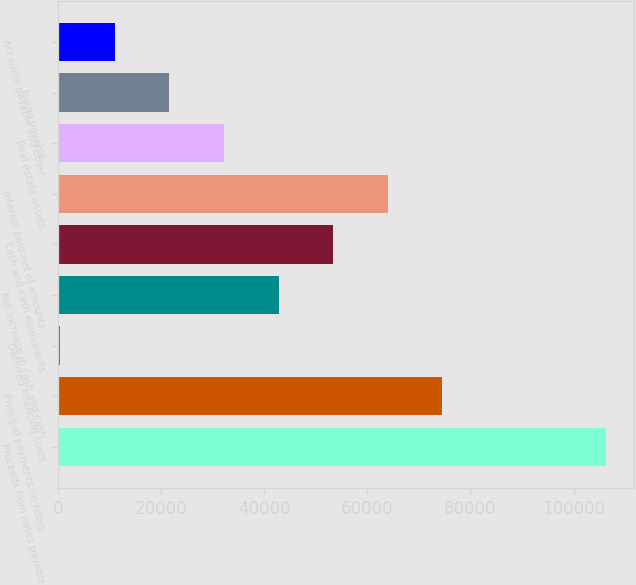Convert chart. <chart><loc_0><loc_0><loc_500><loc_500><bar_chart><fcel>Proceeds from notes payable<fcel>Principal payments on notes<fcel>Deferred financing costs<fcel>Net increase in cash and cash<fcel>Cash and cash equivalents<fcel>Interest paid net of amounts<fcel>Real estate assets<fcel>Notes payable<fcel>Accounts payable and other<nl><fcel>106323<fcel>74552.1<fcel>420<fcel>42781.2<fcel>53371.5<fcel>63961.8<fcel>32190.9<fcel>21600.6<fcel>11010.3<nl></chart> 